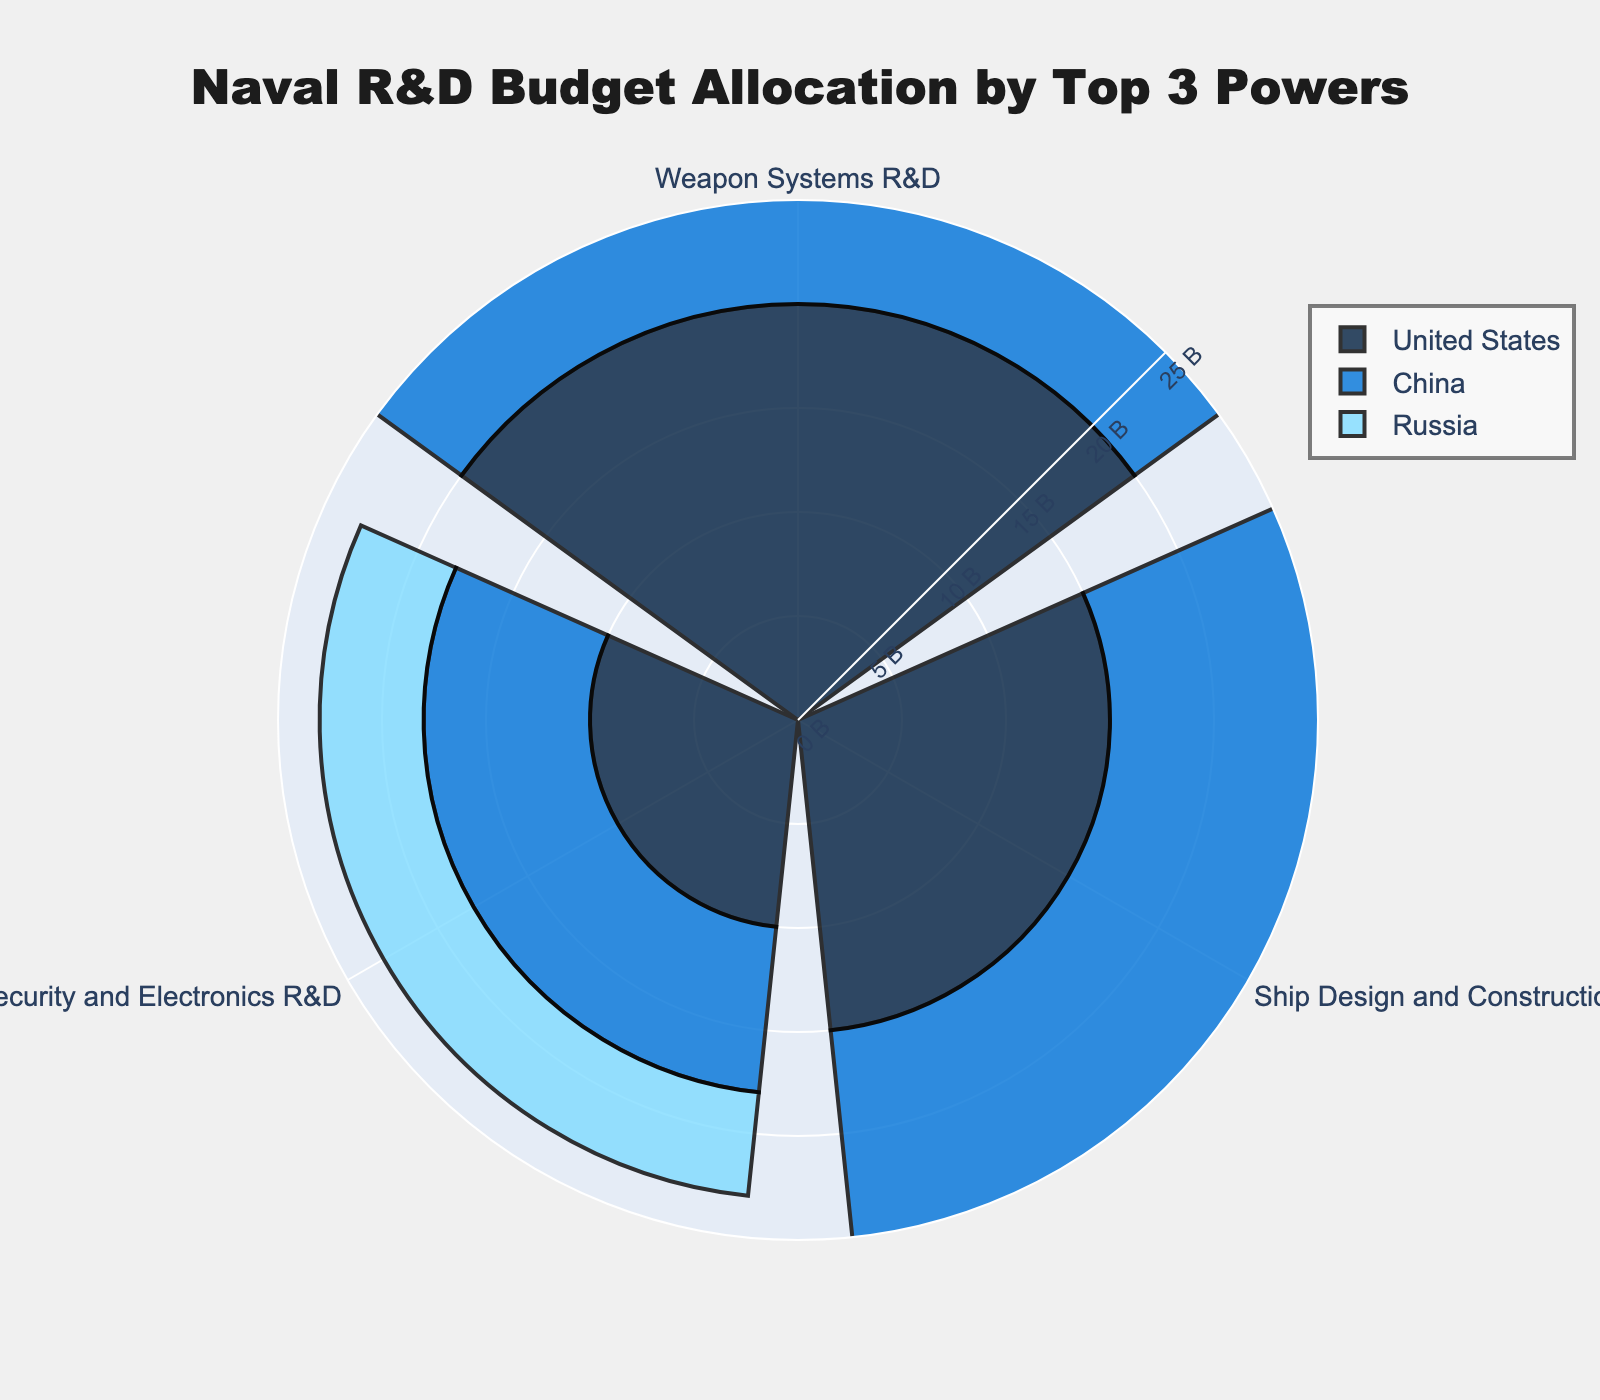What is the total allocation for Weapon Systems R&D? To find the total allocation for Weapon Systems R&D, sum the values for all three countries: United States (20 Billion USD) + China (15 Billion USD) + Russia (10 Billion USD). The result is 20 + 15 + 10 = 45 Billion USD.
Answer: 45 Billion USD Which country has the highest budget allocation for Ship Design and Construction R&D? Compare the amounts allocated to Ship Design and Construction R&D by each country. United States allocates 15 Billion USD, China allocates 12 Billion USD, and Russia allocates 8 Billion USD. The United States has the highest allocation.
Answer: United States How does China's total R&D budget compare to Russia's? Sum the R&D budget categories for China: 15 + 12 + 8 = 35 Billion USD. Sum the R&D budget categories for Russia: 10 + 8 + 5 = 23 Billion USD. Compare the totals: 35 Billion USD (China) vs. 23 Billion USD (Russia). 35 - 23 = 12 Billion USD.
Answer: China spends 12 Billion USD more What percentage of the United States' total R&D budget is allocated to Cybersecurity and Electronics R&D? First, calculate the total R&D budget for the United States: 20 + 15 + 10 = 45 Billion USD. Then, examine the Cybersecurity and Electronics R&D allocation (10 Billion USD). Calculate the percentage: (10 / 45) * 100 ≈ 22.22%.
Answer: 22.22% Which R&D category receives the least funding from China? Compare the R&D allocations for China: Weapon Systems R&D (15 Billion USD), Ship Design and Construction R&D (12 Billion USD), Cybersecurity and Electronics R&D (8 Billion USD). Cybersecurity and Electronics R&D receives the least funding.
Answer: Cybersecurity and Electronics R&D Across all three countries, what is the average allocation for Ship Design and Construction R&D? Sum the Ship Design and Construction R&D allocation for all countries: 15 (United States) + 12 (China) + 8 (Russia) = 35 Billion USD. Divide by the number of countries: 35 / 3 ≈ 11.67 Billion USD.
Answer: 11.67 Billion USD By how much does the United States' allocation for Weapon Systems R&D exceed Russia's allocation for the same category? Subtract Russia's allocation for Weapon Systems R&D (10 Billion USD) from the United States' allocation (20 Billion USD): 20 - 10 = 10 Billion USD.
Answer: 10 Billion USD Which country allocates the smallest portion of its total R&D budget to Ship Design and Construction R&D? Calculate the proportion of Ship Design and Construction R&D to the total R&D budget for each country: United States: 15 / 45 ≈ 0.333, China: 12 / 35 ≈ 0.343, Russia: 8 / 23 ≈ 0.348. The United States allocates the smallest portion.
Answer: United States What is the difference between the highest and lowest allocations for Cybersecurity and Electronics R&D among the countries? Identify the highest allocation (United States: 10 Billion USD) and the lowest (Russia: 5 Billion USD). Subtract the lowest from the highest: 10 - 5 = 5 Billion USD.
Answer: 5 Billion USD 